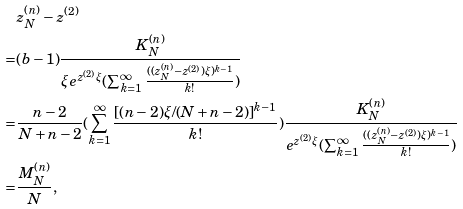Convert formula to latex. <formula><loc_0><loc_0><loc_500><loc_500>& z ^ { ( n ) } _ { N } - z ^ { ( 2 ) } \\ = & ( b - 1 ) \frac { K ^ { ( n ) } _ { N } } { \xi e ^ { z ^ { ( 2 ) } \xi } ( \sum _ { k = 1 } ^ { \infty } \frac { ( ( z ^ { ( n ) } _ { N } - z ^ { ( 2 ) } ) \xi ) ^ { k - 1 } } { k ! } ) } \\ = & \frac { n - 2 } { N + n - 2 } ( \sum _ { k = 1 } ^ { \infty } \frac { [ ( n - 2 ) \xi / ( N + n - 2 ) ] ^ { k - 1 } } { k ! } ) \frac { K ^ { ( n ) } _ { N } } { e ^ { z ^ { ( 2 ) } \xi } ( \sum _ { k = 1 } ^ { \infty } \frac { ( ( z ^ { ( n ) } _ { N } - z ^ { ( 2 ) } ) \xi ) ^ { k - 1 } } { k ! } ) } \\ = & \frac { M ^ { ( n ) } _ { N } } { N } ,</formula> 